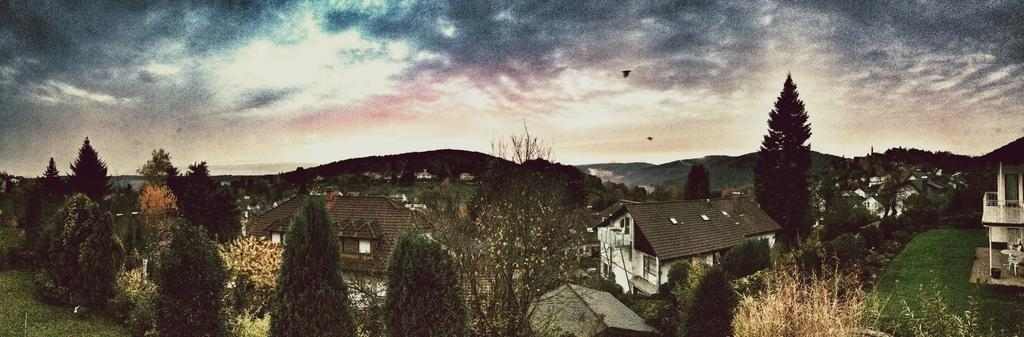What type of structures can be seen in the image? There are houses in the image. What feature is common to the houses and other structures in the image? There are windows in the image. What type of vegetation is present in the image? There are trees in the image. What type of furniture is visible in the image? There is a table and chairs in the image. What is visible in the background of the image? The sky is visible in the image. What type of stem can be seen growing from the table in the image? There is no stem growing from the table in the image. What color is the curtain hanging from the window in the image? There is no curtain present in the image. 